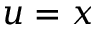Convert formula to latex. <formula><loc_0><loc_0><loc_500><loc_500>u = x</formula> 